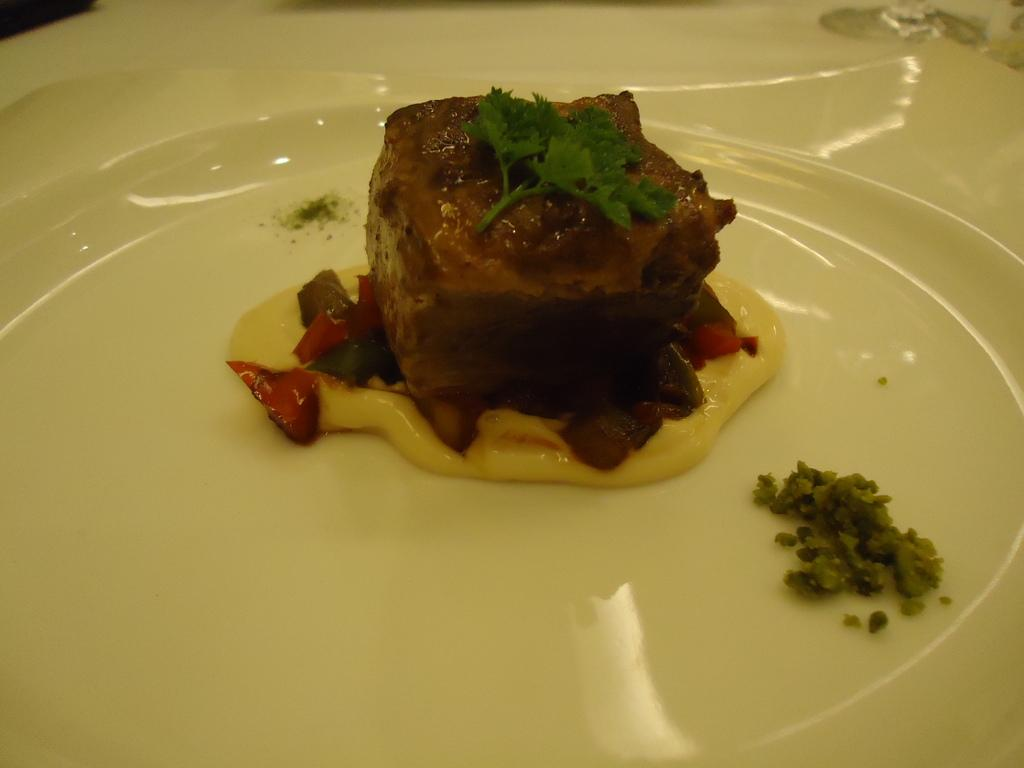What is the main subject of the image? There is a food item on a plate in the image. What type of key is used to open the bottle in the image? There is no key or bottle present in the image; it only features a food item on a plate. 